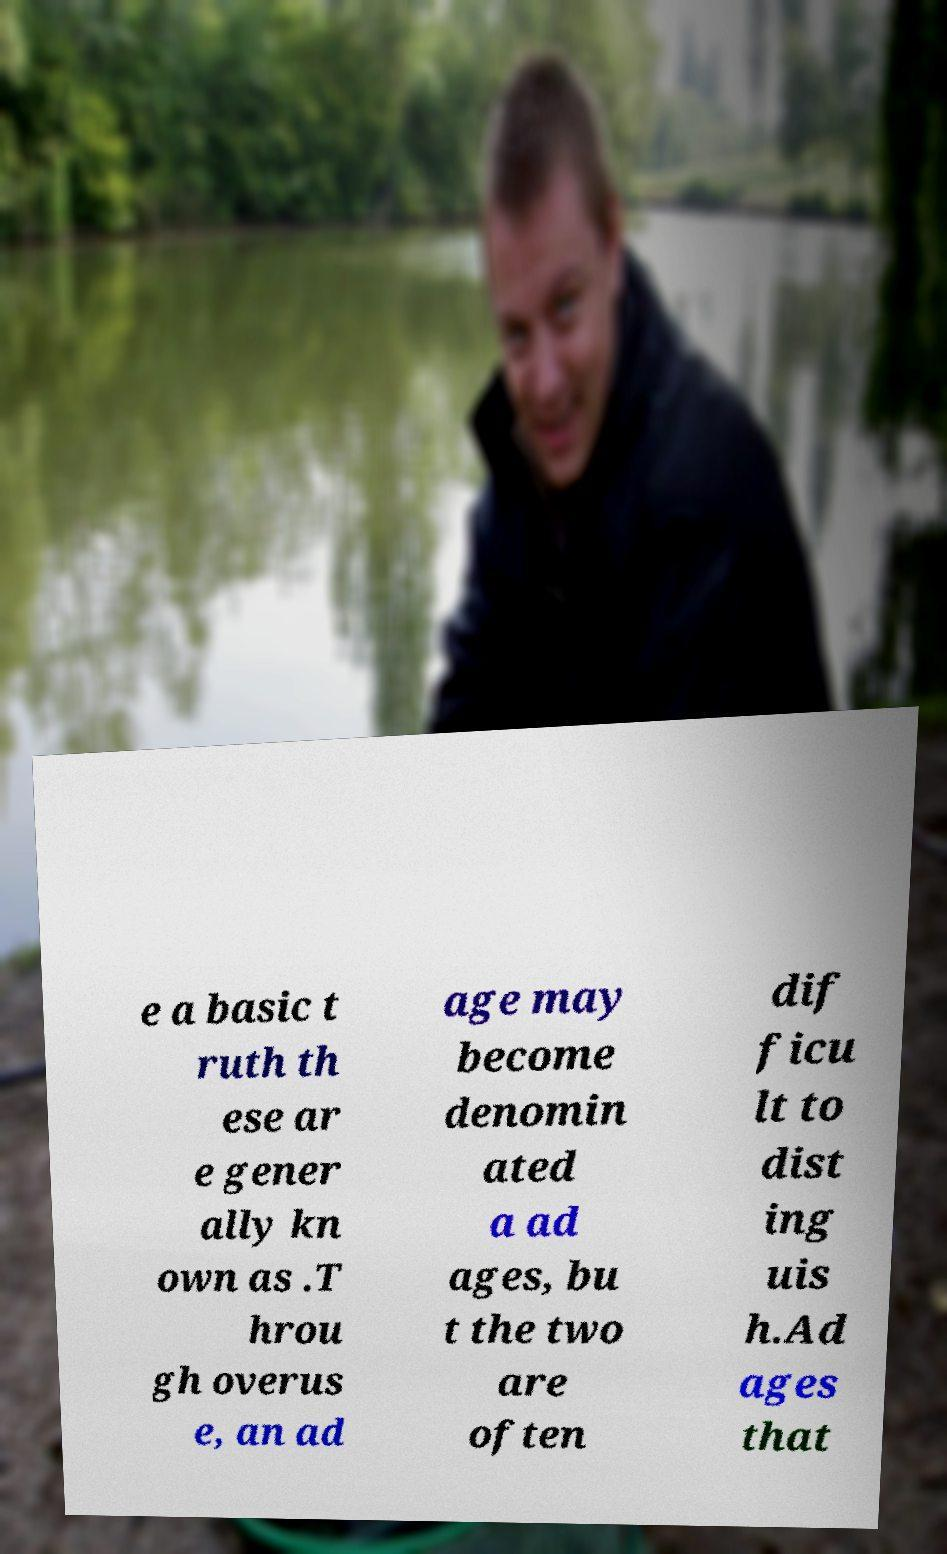What messages or text are displayed in this image? I need them in a readable, typed format. e a basic t ruth th ese ar e gener ally kn own as .T hrou gh overus e, an ad age may become denomin ated a ad ages, bu t the two are often dif ficu lt to dist ing uis h.Ad ages that 